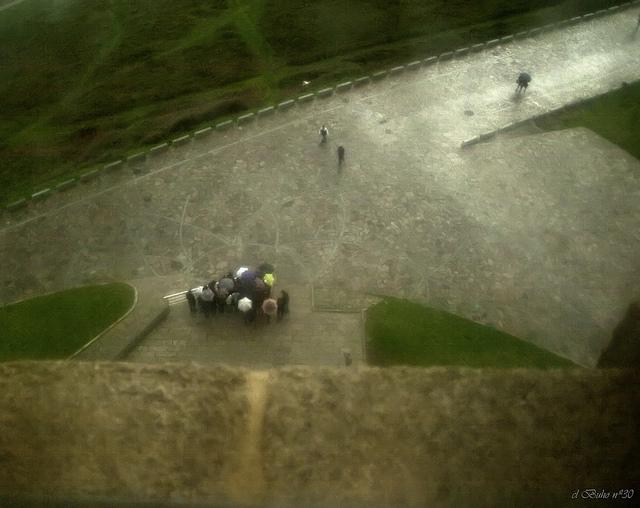Is the ground damp?
Keep it brief. Yes. Is there more pavement or grass?
Be succinct. Pavement. What is on the floor?
Quick response, please. People. 